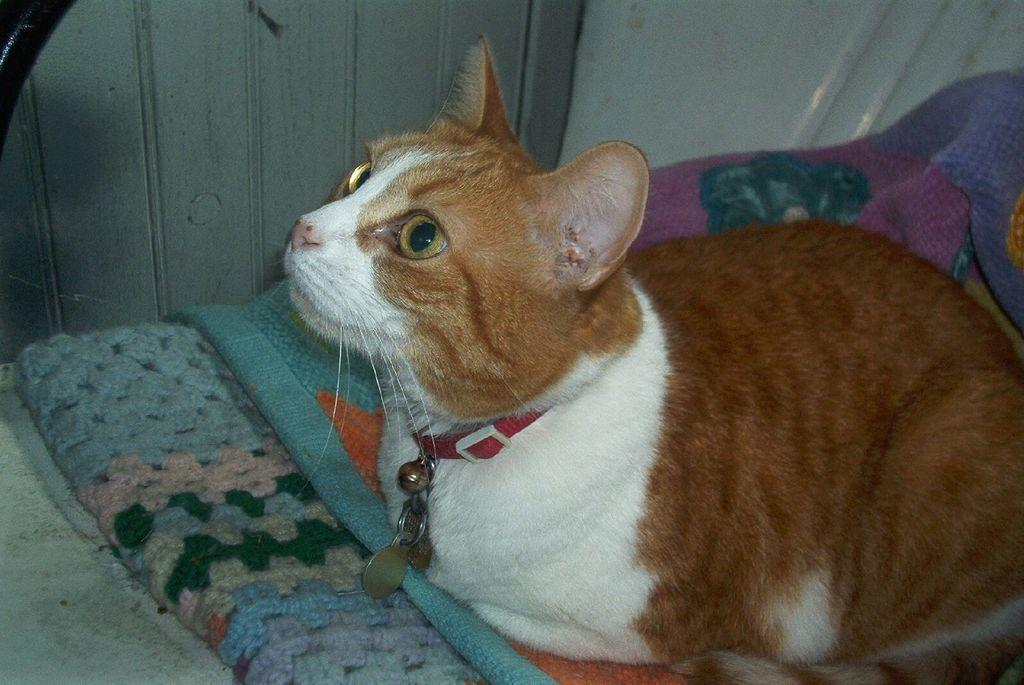What type of animal is in the image? There is a cat in the image. Can you describe the appearance of the cat? The cat is white and brown in color. What is the cat sitting on? The cat is sitting on clothes. What accessory is the cat wearing around its neck? The cat has a belt with lockets around its neck. What can be seen in the background of the image? There is a wall in the background of the image. What type of maid is attending to the cat in the image? There is no maid present in the image; it only features a cat sitting on clothes. What health benefits can be gained from the cat in the image? The image does not provide any information about health benefits related to the cat. 